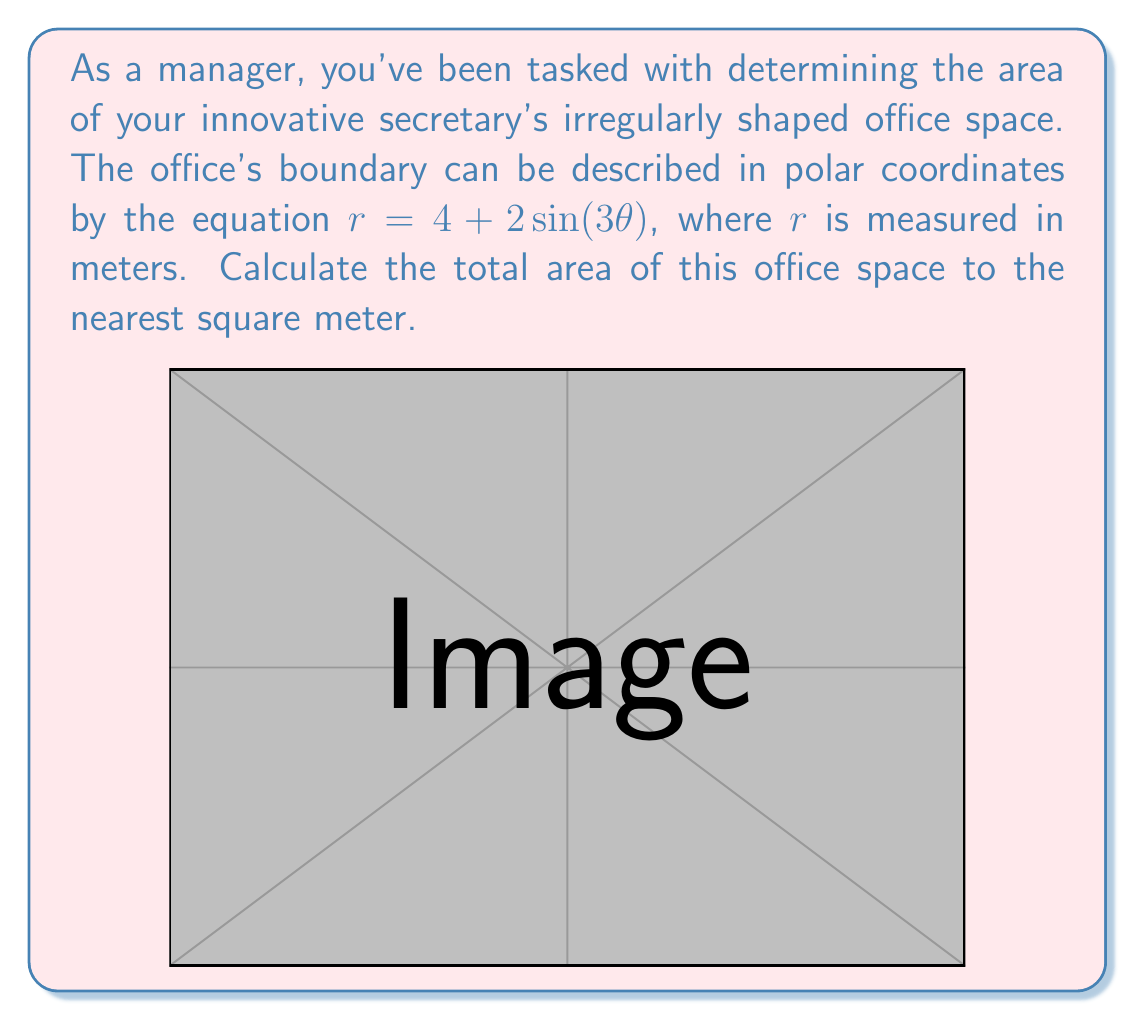Could you help me with this problem? To solve this problem, we'll use the formula for the area of a region in polar coordinates:

$$ A = \frac{1}{2} \int_{0}^{2\pi} r^2(\theta) d\theta $$

Where $r(\theta) = 4 + 2\sin(3\theta)$

Step 1: Square the radius function
$$ r^2(\theta) = (4 + 2\sin(3\theta))^2 = 16 + 16\sin(3\theta) + 4\sin^2(3\theta) $$

Step 2: Set up the integral
$$ A = \frac{1}{2} \int_{0}^{2\pi} (16 + 16\sin(3\theta) + 4\sin^2(3\theta)) d\theta $$

Step 3: Integrate each term
1) $\int_{0}^{2\pi} 16 d\theta = 16\theta \big|_{0}^{2\pi} = 32\pi$
2) $\int_{0}^{2\pi} 16\sin(3\theta) d\theta = -\frac{16}{3}\cos(3\theta) \big|_{0}^{2\pi} = 0$
3) $\int_{0}^{2\pi} 4\sin^2(3\theta) d\theta = 4 \cdot \frac{\theta}{2} - \frac{\sin(6\theta)}{12} \big|_{0}^{2\pi} = 4\pi$

Step 4: Sum the results and multiply by $\frac{1}{2}$
$$ A = \frac{1}{2}(32\pi + 0 + 4\pi) = 18\pi $$

Step 5: Convert to square meters
$$ A = 18\pi \approx 56.55 \text{ m}^2 $$

Rounding to the nearest square meter, we get 57 m².
Answer: 57 m² 